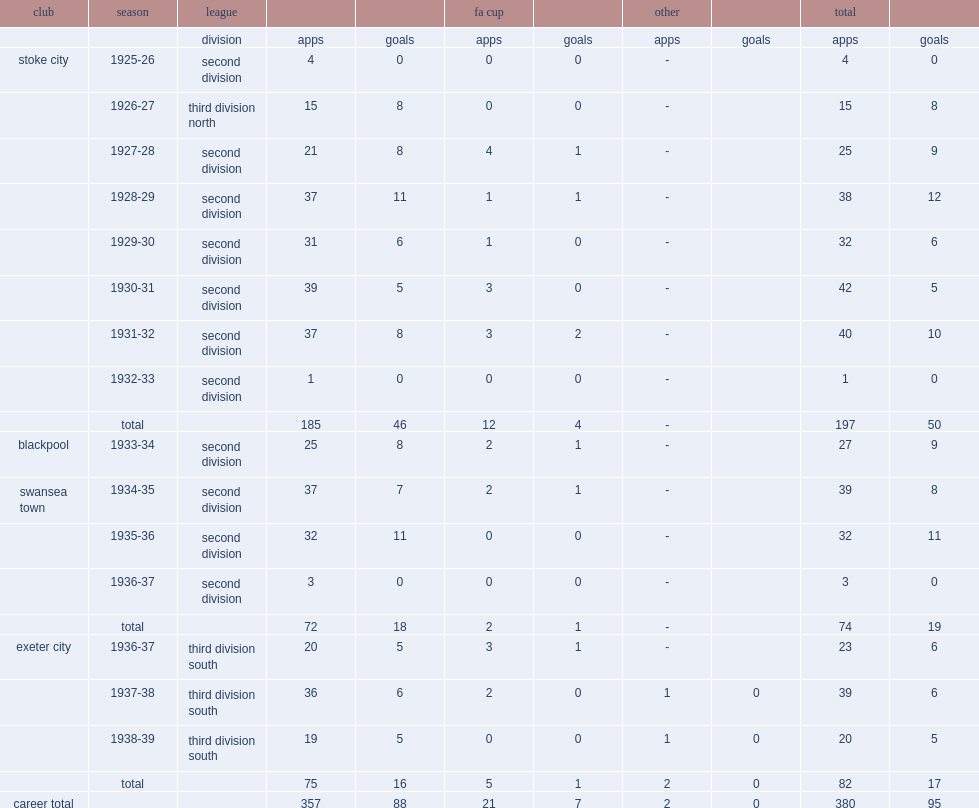What was the number of league appearances made by walter bussey for stoke? 185.0. 